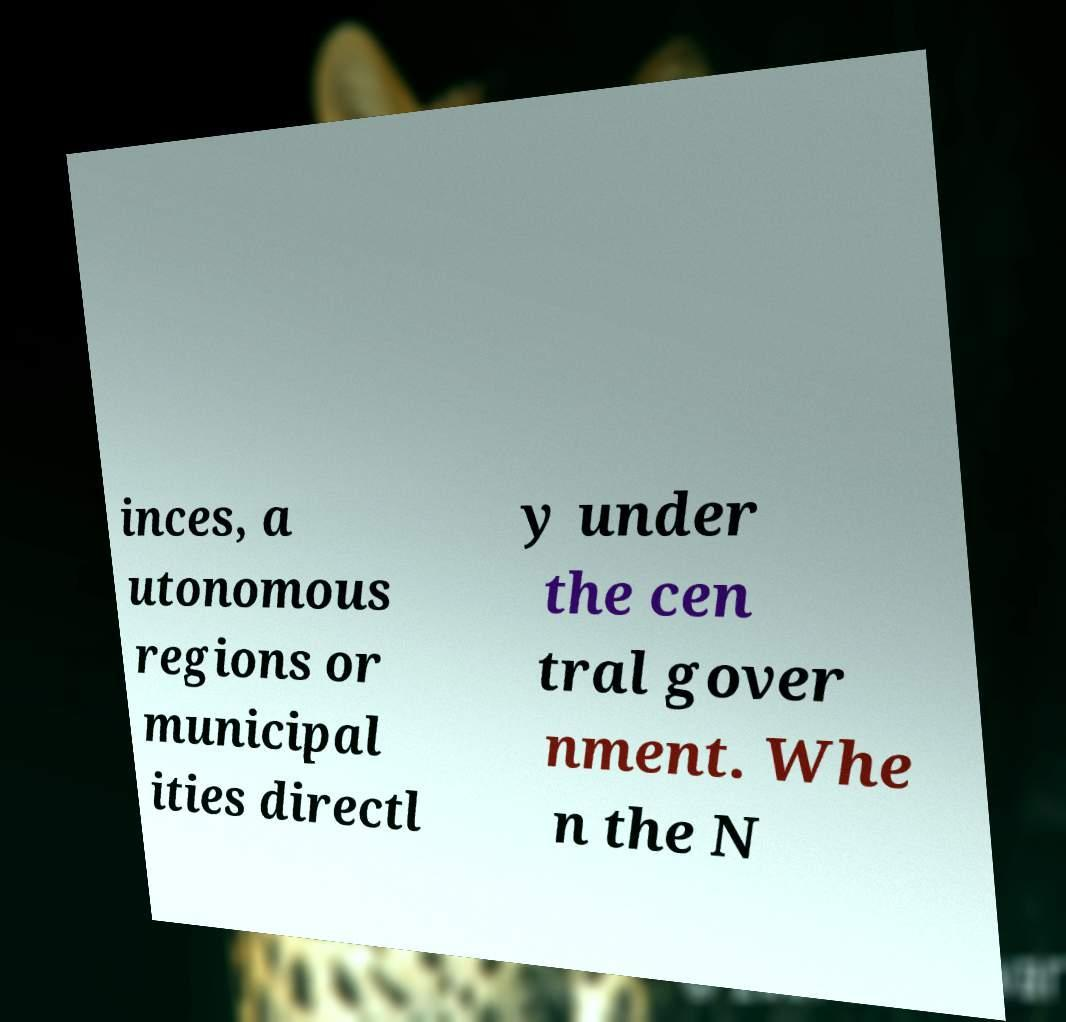I need the written content from this picture converted into text. Can you do that? inces, a utonomous regions or municipal ities directl y under the cen tral gover nment. Whe n the N 